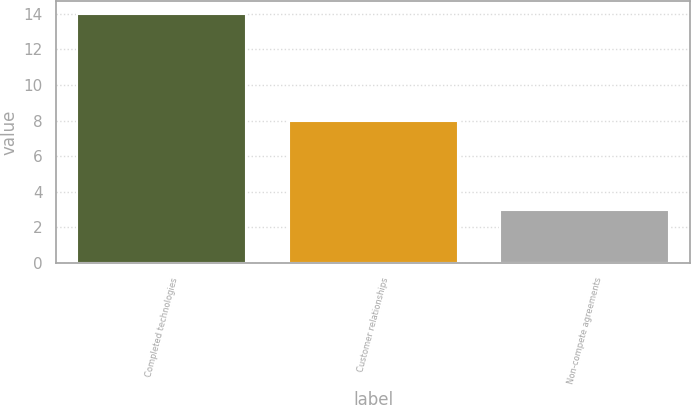Convert chart. <chart><loc_0><loc_0><loc_500><loc_500><bar_chart><fcel>Completed technologies<fcel>Customer relationships<fcel>Non-compete agreements<nl><fcel>14<fcel>8<fcel>3<nl></chart> 